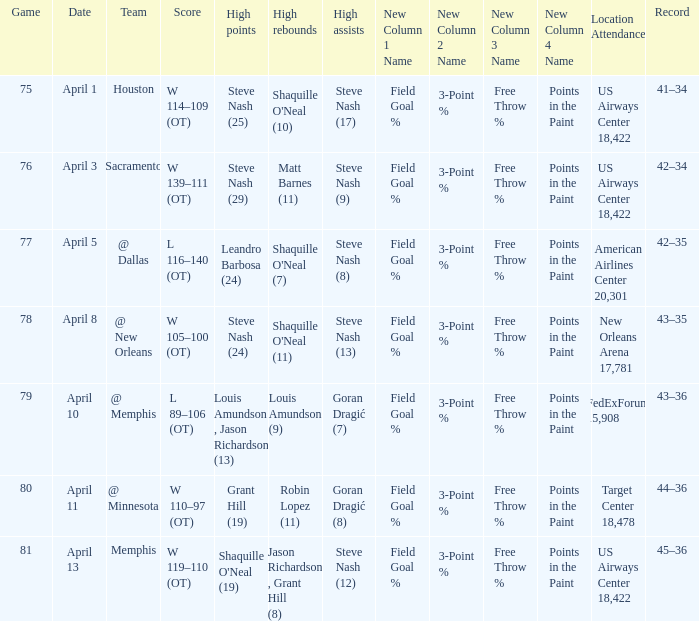Who did the most assists when Matt Barnes (11) got the most rebounds? Steve Nash (9). 